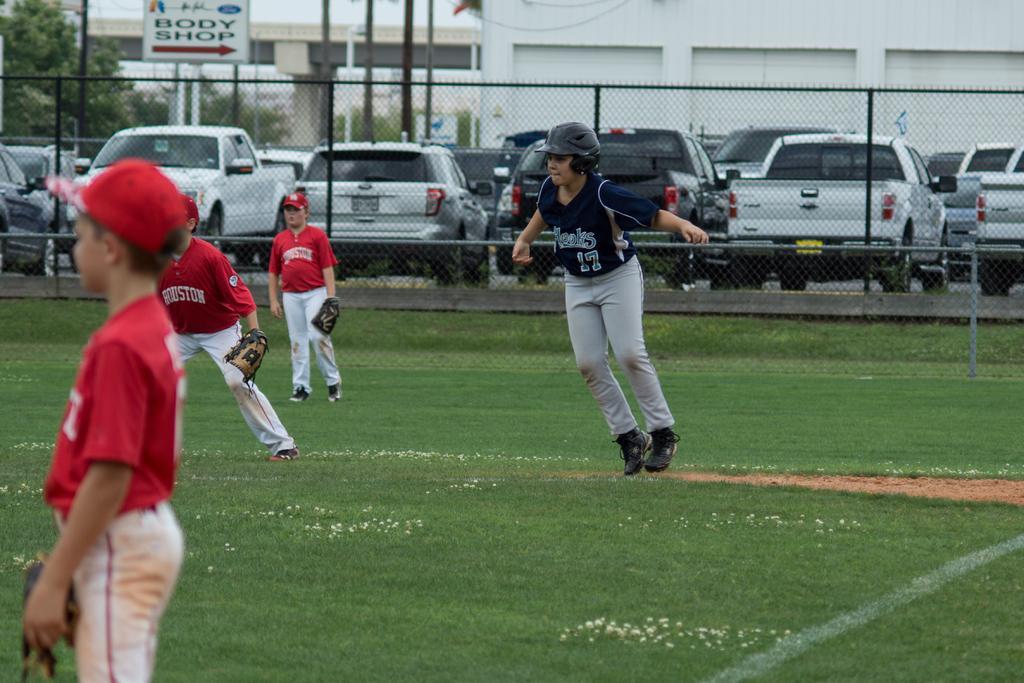Could you give a brief overview of what you see in this image? This is a playing ground. Here I can see four children wearing t-shirts, caps on their heads and standing facing towards the left side. One child is jumping. On the ground, I can see the grass. In the background there is a net fencing. Behind there are many cars, a building and trees. 